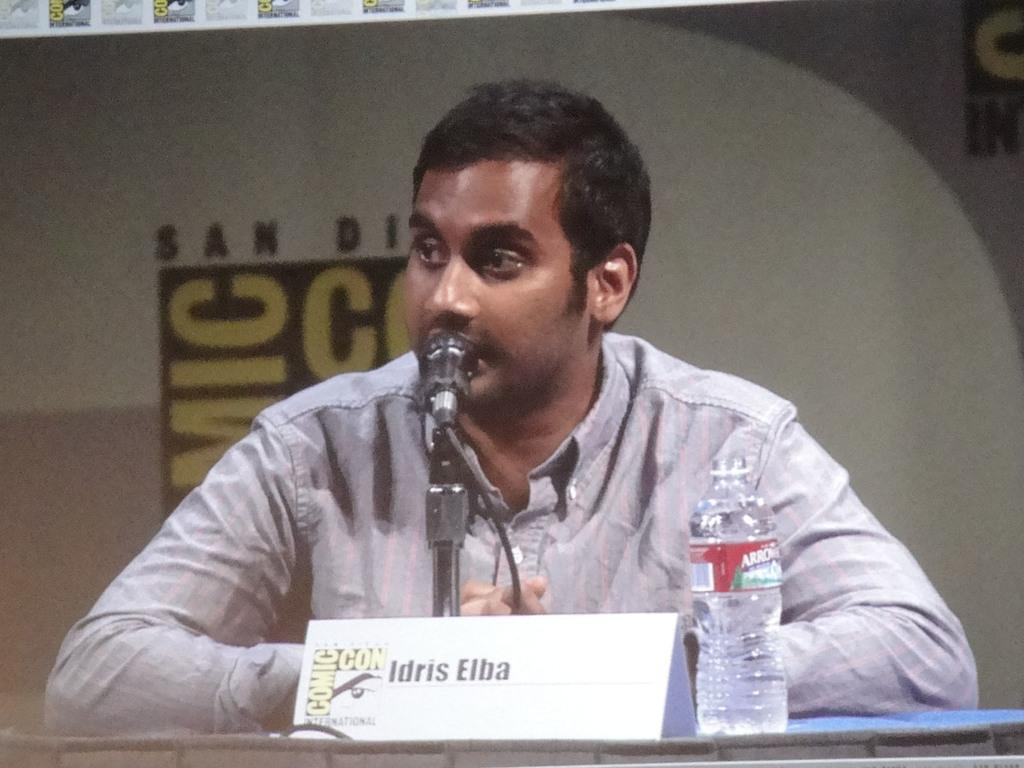What is the person in the image doing? The person is sitting beside a table. What can be seen on the table in the image? The table contains a mic with a stand, a name board, and a bottle. What might the person be using the mic for? The person might be using the mic for recording or speaking into. What is the purpose of the name board on the table? The name board might be used to display the person's name or the name of the event. How does the beggar interact with the person sitting beside the table in the image? There is no beggar present in the image; it only shows a person sitting beside a table with a mic, a name board, and a bottle. 